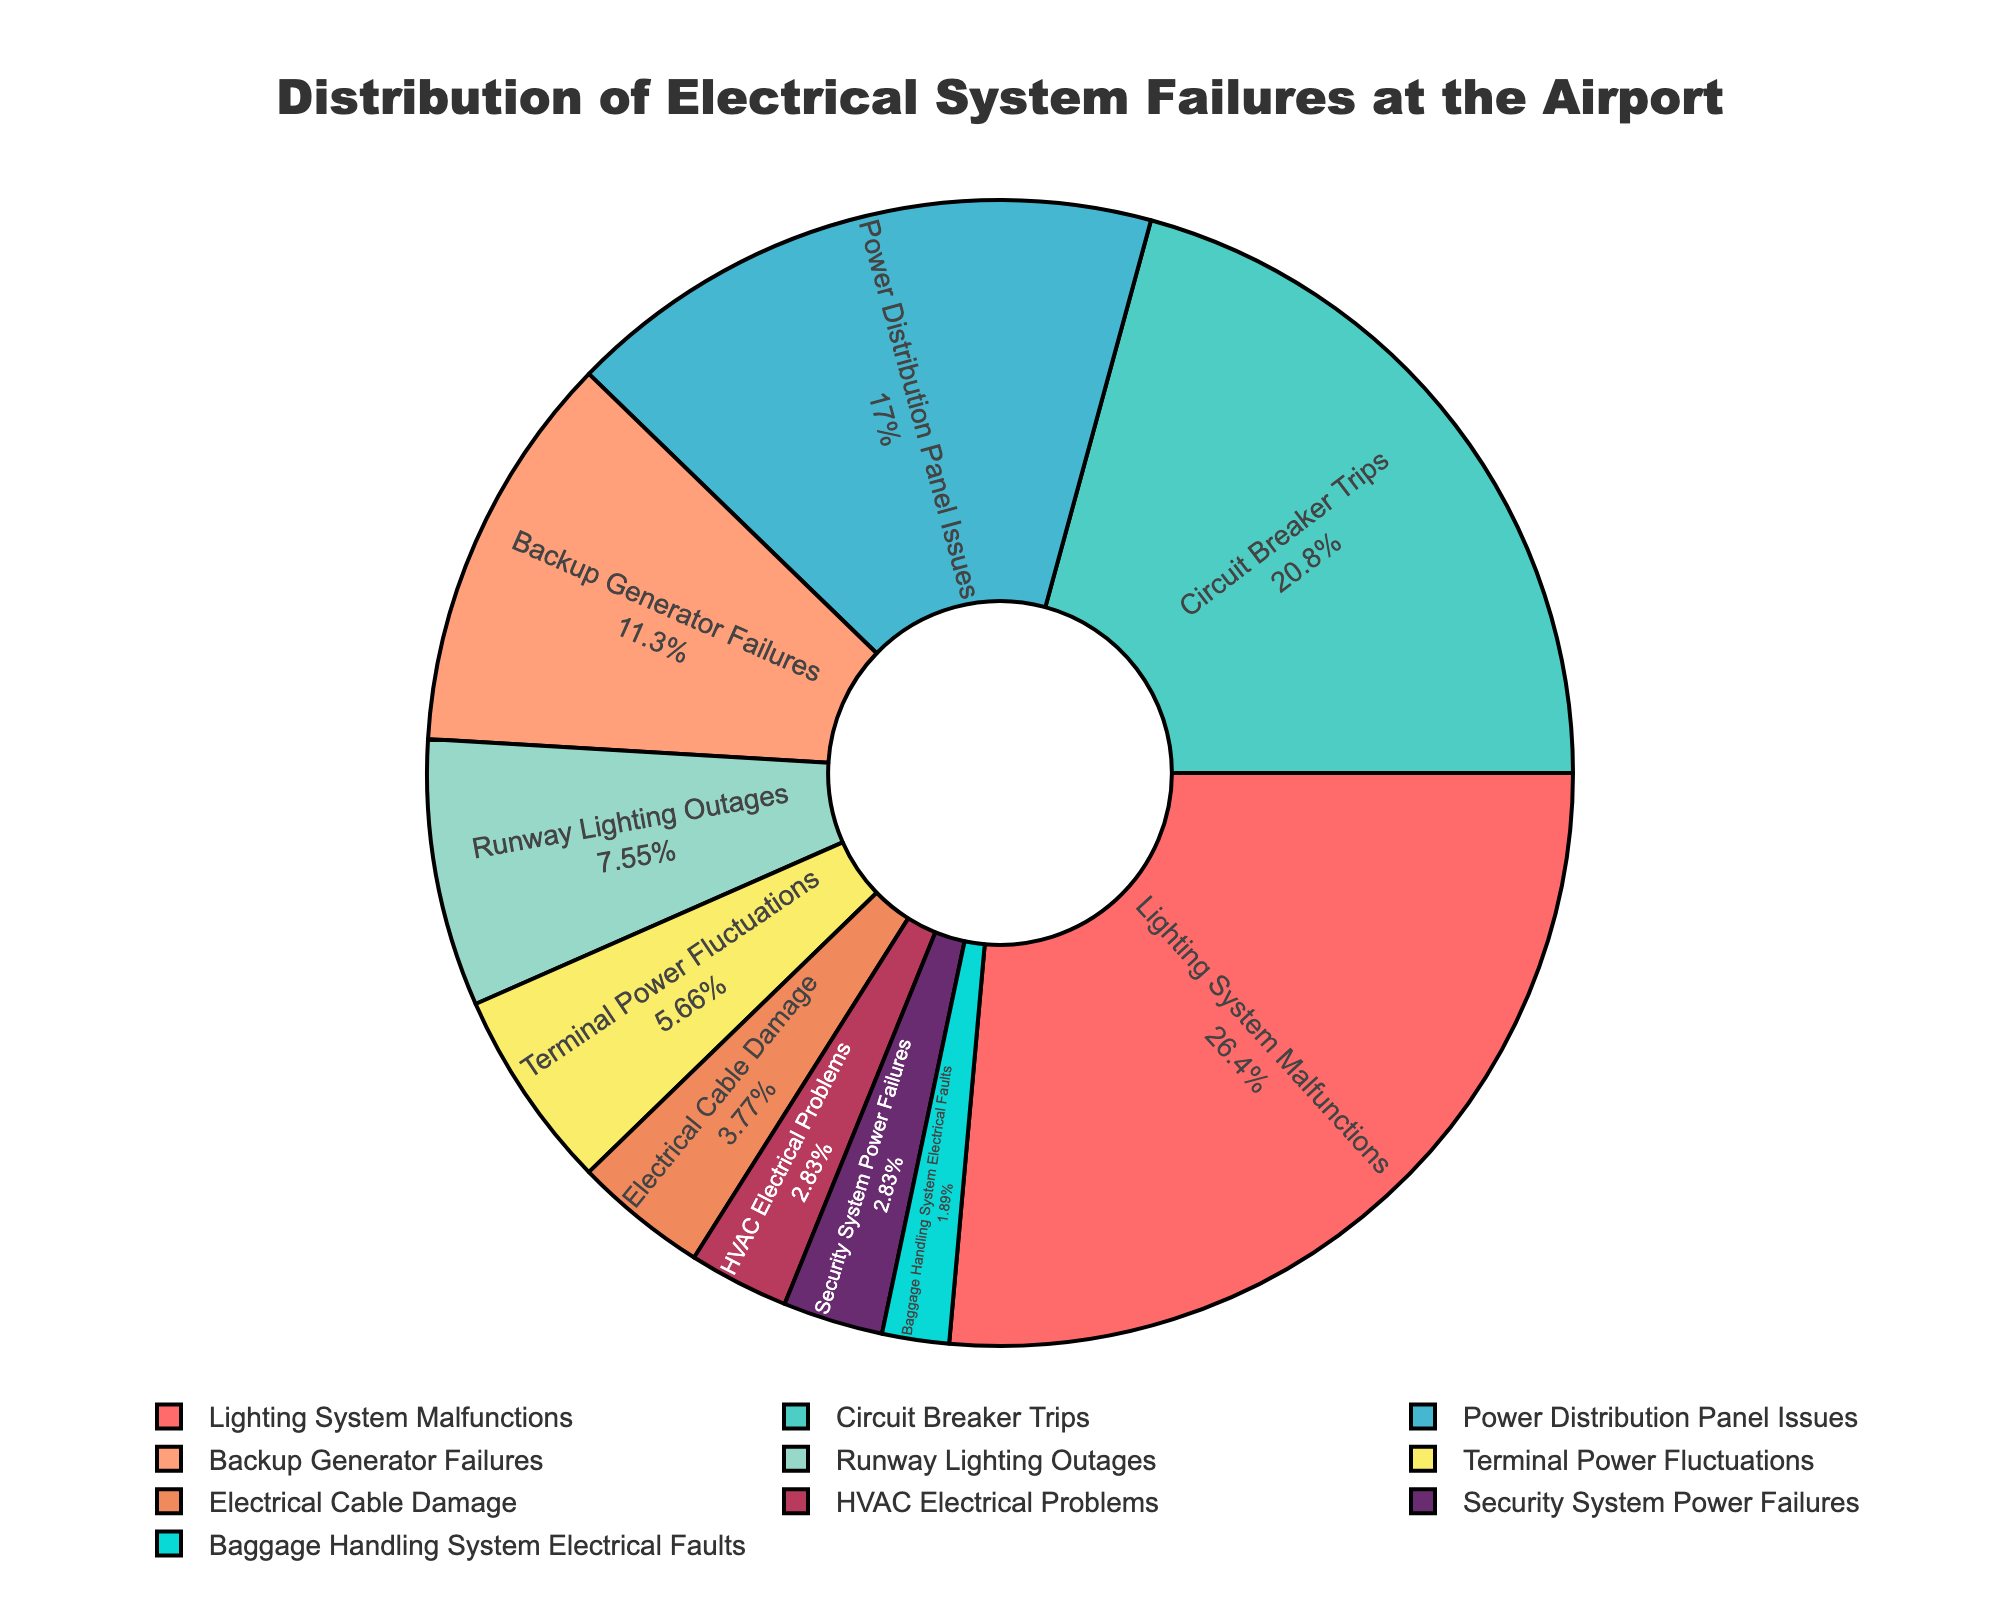Which type of failure has the highest percentage? Identify the largest section of the pie chart by looking at the labels and associated percentages. The section labeled "Lighting System Malfunctions" has the largest portion, which means it has the highest percentage.
Answer: Lighting System Malfunctions How much larger is the percentage of Circuit Breaker Trips compared to Terminal Power Fluctuations? Locate the sections of the pie chart labeled "Circuit Breaker Trips" and "Terminal Power Fluctuations." Circuit Breaker Trips have a percentage of 22% and Terminal Power Fluctuations have 6%. Subtract the smaller percentage from the larger one (22% - 6% = 16%).
Answer: 16% Which type of failure accounts for exactly 12% of the electrical system failures? Locate the section of the pie chart labeled with a percentage of 12%. In this case, it corresponds to "Backup Generator Failures."
Answer: Backup Generator Failures What is the combined percentage of Lighting System Malfunctions and Circuit Breaker Trips? Sum the percentages of "Lighting System Malfunctions" (28%) and "Circuit Breaker Trips" (22%). The total is 28% + 22% = 50%.
Answer: 50% Which three types of failures have the lowest percentages, and what are their combined total? Identify the sections with the smallest percentages: "Baggage Handling System Electrical Faults" (2%), "HVAC Electrical Problems" (3%), and "Security System Power Failures" (3%). Sum these values (2% + 3% + 3% = 8%).
Answer: Baggage Handling System Electrical Faults, HVAC Electrical Problems, Security System Power Failures; 8% What percentage of the electrical system failures is accounted for by issues with the Power Distribution Panel and Backup Generator combined? Add the percentages for "Power Distribution Panel Issues" (18%) and "Backup Generator Failures" (12%) together. The sum is 18% + 12% = 30%.
Answer: 30% Is the percentage of Electrical Cable Damage greater or less than the percentage of Runway Lighting Outages? Compare the percentages for "Electrical Cable Damage" (4%) and "Runway Lighting Outages" (8%). Since 4% is less than 8%, Electrical Cable Damage has a smaller percentage.
Answer: Less How does the percentage for HVAC Electrical Problems compare to Security System Power Failures? Both "HVAC Electrical Problems" and "Security System Power Failures" have the same percentage of 3%.
Answer: Equal What is the total percentage for all types of failures not related to lighting (including runway and terminal)? Exclude "Lighting System Malfunctions" (28%) and "Runway Lighting Outages" (8%). Sum the remaining percentages: 22% (Circuit Breaker Trips) + 18% (Power Distribution Panel Issues) + 12% (Backup Generator Failures) + 6% (Terminal Power Fluctuations) + 4% (Electrical Cable Damage) + 3% (HVAC Electrical Problems) + 3% (Security System Power Failures) + 2% (Baggage Handling System Electrical Faults). The total is 22% + 18% + 12% + 6% + 4% + 3% + 3% + 2% = 70%.
Answer: 70% What is the visual distinction of Circuit Breaker Trips in the pie chart? Observe that the section for "Circuit Breaker Trips" is the second largest part of the pie chart and would be colored differently compared to other sections, making it easy to identify visually.
Answer: Second largest section 